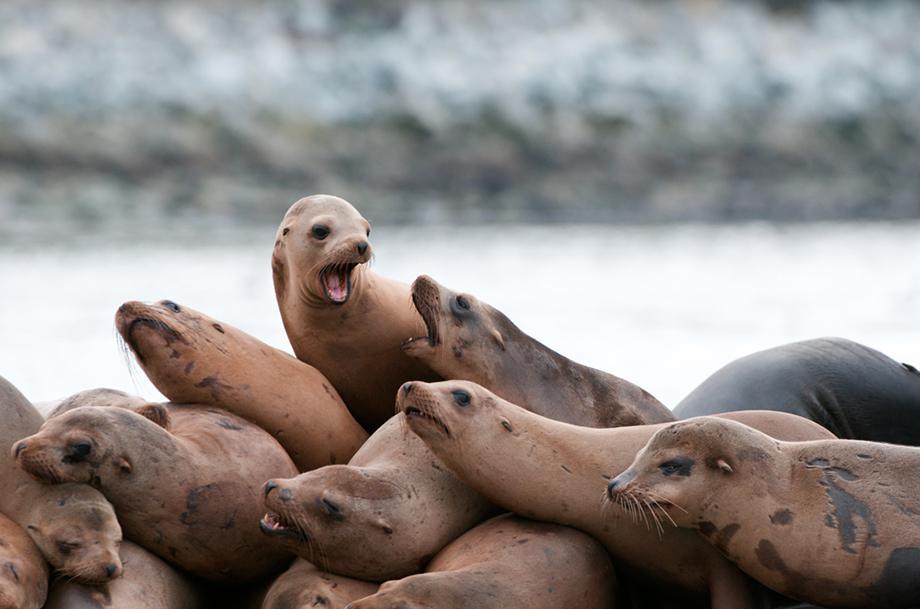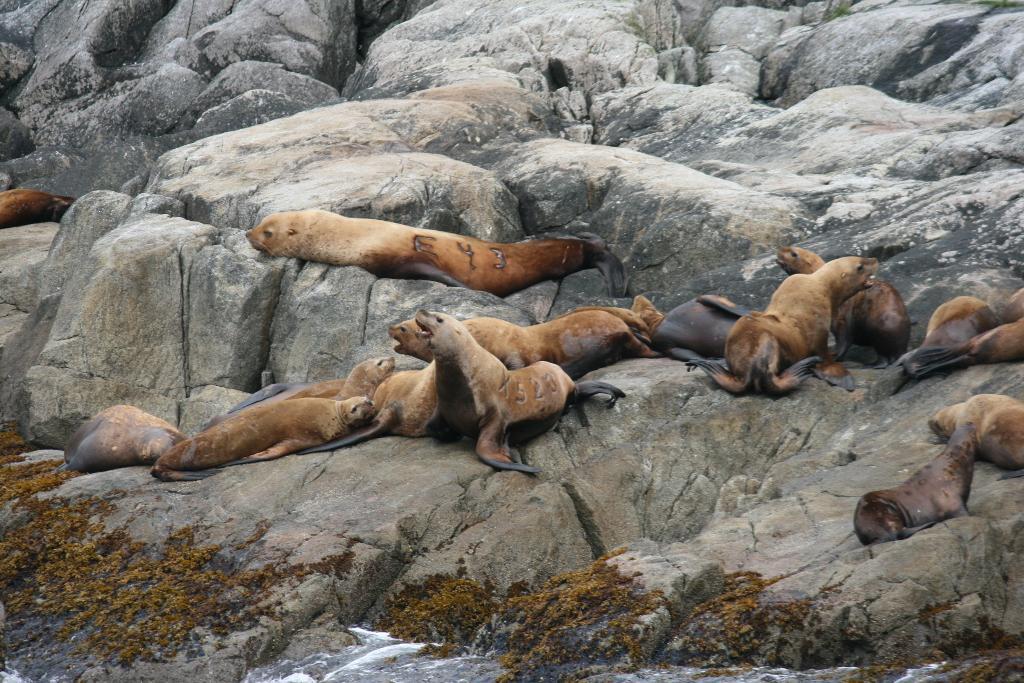The first image is the image on the left, the second image is the image on the right. Examine the images to the left and right. Is the description "Waves are coming onto the beach." accurate? Answer yes or no. No. 